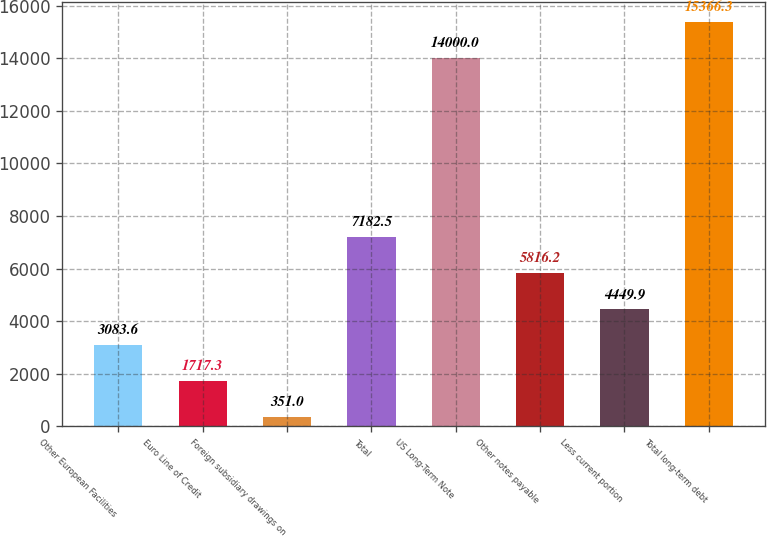Convert chart. <chart><loc_0><loc_0><loc_500><loc_500><bar_chart><fcel>Other European Facilities<fcel>Euro Line of Credit<fcel>Foreign subsidiary drawings on<fcel>Total<fcel>US Long-Term Note<fcel>Other notes payable<fcel>Less current portion<fcel>Total long-term debt<nl><fcel>3083.6<fcel>1717.3<fcel>351<fcel>7182.5<fcel>14000<fcel>5816.2<fcel>4449.9<fcel>15366.3<nl></chart> 